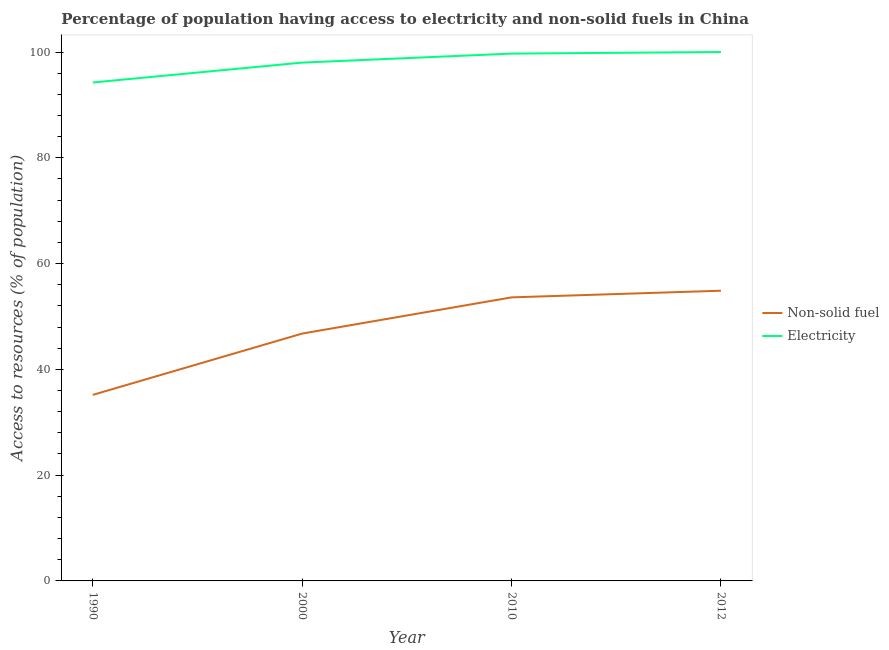Does the line corresponding to percentage of population having access to non-solid fuel intersect with the line corresponding to percentage of population having access to electricity?
Provide a succinct answer. No. Is the number of lines equal to the number of legend labels?
Give a very brief answer. Yes. Across all years, what is the maximum percentage of population having access to non-solid fuel?
Ensure brevity in your answer.  54.87. Across all years, what is the minimum percentage of population having access to electricity?
Your answer should be very brief. 94.24. In which year was the percentage of population having access to electricity maximum?
Give a very brief answer. 2012. In which year was the percentage of population having access to electricity minimum?
Provide a short and direct response. 1990. What is the total percentage of population having access to electricity in the graph?
Your response must be concise. 391.94. What is the difference between the percentage of population having access to non-solid fuel in 2000 and that in 2012?
Give a very brief answer. -8.1. What is the difference between the percentage of population having access to non-solid fuel in 1990 and the percentage of population having access to electricity in 2000?
Offer a very short reply. -62.82. What is the average percentage of population having access to electricity per year?
Provide a short and direct response. 97.98. In the year 2010, what is the difference between the percentage of population having access to non-solid fuel and percentage of population having access to electricity?
Give a very brief answer. -46.09. Is the percentage of population having access to electricity in 1990 less than that in 2012?
Offer a very short reply. Yes. What is the difference between the highest and the second highest percentage of population having access to non-solid fuel?
Give a very brief answer. 1.26. What is the difference between the highest and the lowest percentage of population having access to electricity?
Your answer should be very brief. 5.76. Is the sum of the percentage of population having access to electricity in 1990 and 2000 greater than the maximum percentage of population having access to non-solid fuel across all years?
Your answer should be compact. Yes. Does the percentage of population having access to non-solid fuel monotonically increase over the years?
Keep it short and to the point. Yes. Is the percentage of population having access to non-solid fuel strictly greater than the percentage of population having access to electricity over the years?
Ensure brevity in your answer.  No. Is the percentage of population having access to electricity strictly less than the percentage of population having access to non-solid fuel over the years?
Make the answer very short. No. How many years are there in the graph?
Your answer should be very brief. 4. Are the values on the major ticks of Y-axis written in scientific E-notation?
Your answer should be very brief. No. How many legend labels are there?
Make the answer very short. 2. What is the title of the graph?
Your response must be concise. Percentage of population having access to electricity and non-solid fuels in China. Does "Stunting" appear as one of the legend labels in the graph?
Your response must be concise. No. What is the label or title of the Y-axis?
Your answer should be compact. Access to resources (% of population). What is the Access to resources (% of population) of Non-solid fuel in 1990?
Offer a terse response. 35.18. What is the Access to resources (% of population) of Electricity in 1990?
Keep it short and to the point. 94.24. What is the Access to resources (% of population) in Non-solid fuel in 2000?
Your answer should be very brief. 46.77. What is the Access to resources (% of population) in Electricity in 2000?
Your answer should be very brief. 98. What is the Access to resources (% of population) in Non-solid fuel in 2010?
Keep it short and to the point. 53.61. What is the Access to resources (% of population) in Electricity in 2010?
Your answer should be very brief. 99.7. What is the Access to resources (% of population) in Non-solid fuel in 2012?
Make the answer very short. 54.87. What is the Access to resources (% of population) in Electricity in 2012?
Your answer should be very brief. 100. Across all years, what is the maximum Access to resources (% of population) of Non-solid fuel?
Provide a succinct answer. 54.87. Across all years, what is the maximum Access to resources (% of population) of Electricity?
Provide a succinct answer. 100. Across all years, what is the minimum Access to resources (% of population) of Non-solid fuel?
Provide a short and direct response. 35.18. Across all years, what is the minimum Access to resources (% of population) of Electricity?
Offer a very short reply. 94.24. What is the total Access to resources (% of population) of Non-solid fuel in the graph?
Make the answer very short. 190.42. What is the total Access to resources (% of population) in Electricity in the graph?
Provide a short and direct response. 391.94. What is the difference between the Access to resources (% of population) in Non-solid fuel in 1990 and that in 2000?
Your response must be concise. -11.59. What is the difference between the Access to resources (% of population) of Electricity in 1990 and that in 2000?
Give a very brief answer. -3.76. What is the difference between the Access to resources (% of population) in Non-solid fuel in 1990 and that in 2010?
Provide a short and direct response. -18.43. What is the difference between the Access to resources (% of population) of Electricity in 1990 and that in 2010?
Provide a short and direct response. -5.46. What is the difference between the Access to resources (% of population) of Non-solid fuel in 1990 and that in 2012?
Give a very brief answer. -19.69. What is the difference between the Access to resources (% of population) in Electricity in 1990 and that in 2012?
Your answer should be compact. -5.76. What is the difference between the Access to resources (% of population) in Non-solid fuel in 2000 and that in 2010?
Your answer should be very brief. -6.84. What is the difference between the Access to resources (% of population) of Non-solid fuel in 2000 and that in 2012?
Offer a very short reply. -8.1. What is the difference between the Access to resources (% of population) of Electricity in 2000 and that in 2012?
Make the answer very short. -2. What is the difference between the Access to resources (% of population) of Non-solid fuel in 2010 and that in 2012?
Provide a succinct answer. -1.26. What is the difference between the Access to resources (% of population) in Electricity in 2010 and that in 2012?
Your response must be concise. -0.3. What is the difference between the Access to resources (% of population) in Non-solid fuel in 1990 and the Access to resources (% of population) in Electricity in 2000?
Offer a terse response. -62.82. What is the difference between the Access to resources (% of population) of Non-solid fuel in 1990 and the Access to resources (% of population) of Electricity in 2010?
Provide a short and direct response. -64.52. What is the difference between the Access to resources (% of population) in Non-solid fuel in 1990 and the Access to resources (% of population) in Electricity in 2012?
Provide a short and direct response. -64.82. What is the difference between the Access to resources (% of population) of Non-solid fuel in 2000 and the Access to resources (% of population) of Electricity in 2010?
Give a very brief answer. -52.93. What is the difference between the Access to resources (% of population) in Non-solid fuel in 2000 and the Access to resources (% of population) in Electricity in 2012?
Provide a short and direct response. -53.23. What is the difference between the Access to resources (% of population) in Non-solid fuel in 2010 and the Access to resources (% of population) in Electricity in 2012?
Provide a succinct answer. -46.39. What is the average Access to resources (% of population) of Non-solid fuel per year?
Your response must be concise. 47.61. What is the average Access to resources (% of population) in Electricity per year?
Provide a short and direct response. 97.98. In the year 1990, what is the difference between the Access to resources (% of population) in Non-solid fuel and Access to resources (% of population) in Electricity?
Ensure brevity in your answer.  -59.06. In the year 2000, what is the difference between the Access to resources (% of population) in Non-solid fuel and Access to resources (% of population) in Electricity?
Your answer should be compact. -51.23. In the year 2010, what is the difference between the Access to resources (% of population) of Non-solid fuel and Access to resources (% of population) of Electricity?
Ensure brevity in your answer.  -46.09. In the year 2012, what is the difference between the Access to resources (% of population) of Non-solid fuel and Access to resources (% of population) of Electricity?
Make the answer very short. -45.13. What is the ratio of the Access to resources (% of population) in Non-solid fuel in 1990 to that in 2000?
Give a very brief answer. 0.75. What is the ratio of the Access to resources (% of population) in Electricity in 1990 to that in 2000?
Ensure brevity in your answer.  0.96. What is the ratio of the Access to resources (% of population) of Non-solid fuel in 1990 to that in 2010?
Make the answer very short. 0.66. What is the ratio of the Access to resources (% of population) of Electricity in 1990 to that in 2010?
Offer a very short reply. 0.95. What is the ratio of the Access to resources (% of population) of Non-solid fuel in 1990 to that in 2012?
Offer a very short reply. 0.64. What is the ratio of the Access to resources (% of population) in Electricity in 1990 to that in 2012?
Offer a very short reply. 0.94. What is the ratio of the Access to resources (% of population) of Non-solid fuel in 2000 to that in 2010?
Offer a very short reply. 0.87. What is the ratio of the Access to resources (% of population) in Electricity in 2000 to that in 2010?
Offer a terse response. 0.98. What is the ratio of the Access to resources (% of population) in Non-solid fuel in 2000 to that in 2012?
Give a very brief answer. 0.85. What is the ratio of the Access to resources (% of population) in Electricity in 2000 to that in 2012?
Provide a short and direct response. 0.98. What is the ratio of the Access to resources (% of population) of Non-solid fuel in 2010 to that in 2012?
Make the answer very short. 0.98. What is the ratio of the Access to resources (% of population) in Electricity in 2010 to that in 2012?
Your response must be concise. 1. What is the difference between the highest and the second highest Access to resources (% of population) of Non-solid fuel?
Your answer should be compact. 1.26. What is the difference between the highest and the second highest Access to resources (% of population) of Electricity?
Ensure brevity in your answer.  0.3. What is the difference between the highest and the lowest Access to resources (% of population) in Non-solid fuel?
Offer a terse response. 19.69. What is the difference between the highest and the lowest Access to resources (% of population) in Electricity?
Your response must be concise. 5.76. 